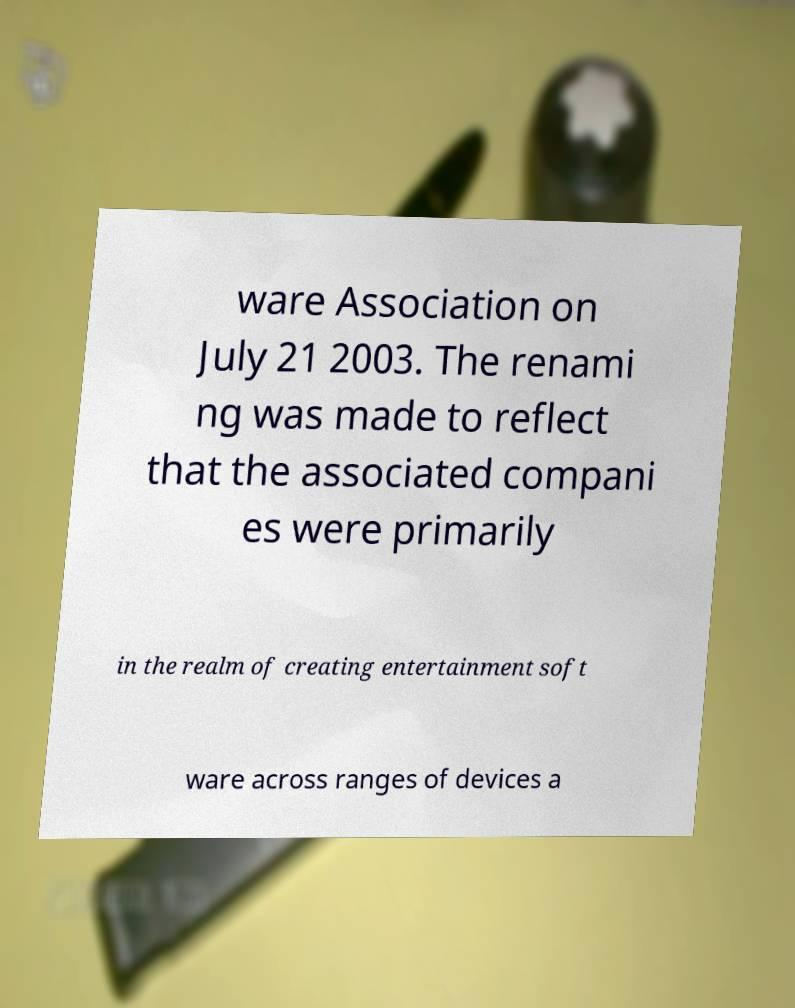I need the written content from this picture converted into text. Can you do that? ware Association on July 21 2003. The renami ng was made to reflect that the associated compani es were primarily in the realm of creating entertainment soft ware across ranges of devices a 